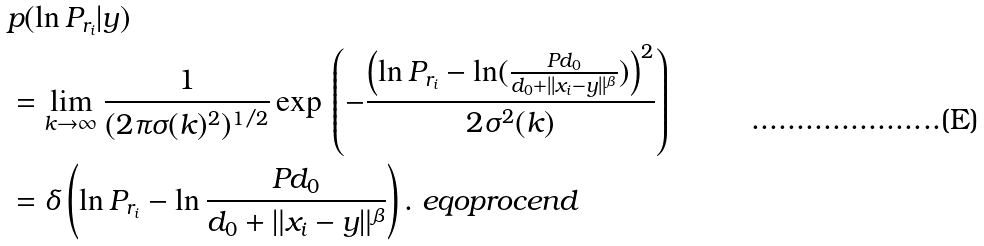<formula> <loc_0><loc_0><loc_500><loc_500>& p ( \ln P _ { r _ { i } } | y ) \\ & = \lim _ { k \rightarrow \infty } \frac { 1 } { ( 2 \pi \sigma ( k ) ^ { 2 } ) ^ { 1 / 2 } } \exp \, \left ( - \frac { \left ( \ln P _ { r _ { i } } - \ln ( \frac { P d _ { 0 } } { d _ { 0 } + | | x _ { i } - y | | ^ { \beta } } ) \right ) ^ { 2 } } { 2 \sigma ^ { 2 } ( k ) } \right ) \\ & = \delta \left ( \ln P _ { r _ { i } } - \ln \frac { P d _ { 0 } } { d _ { 0 } + \| x _ { i } - y \| ^ { \beta } } \right ) . \ e q o p r o c e n d</formula> 